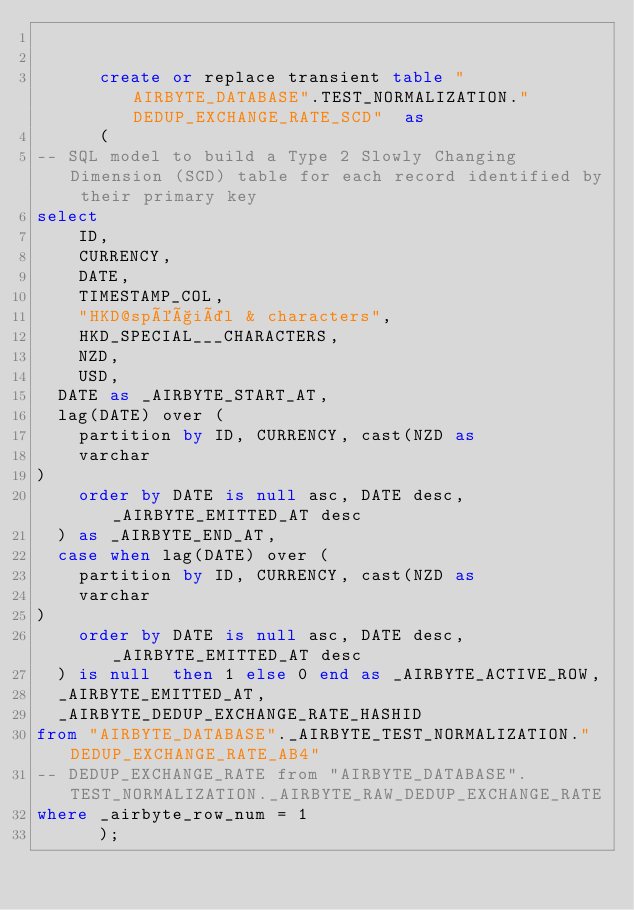<code> <loc_0><loc_0><loc_500><loc_500><_SQL_>

      create or replace transient table "AIRBYTE_DATABASE".TEST_NORMALIZATION."DEDUP_EXCHANGE_RATE_SCD"  as
      (
-- SQL model to build a Type 2 Slowly Changing Dimension (SCD) table for each record identified by their primary key
select
    ID,
    CURRENCY,
    DATE,
    TIMESTAMP_COL,
    "HKD@spéçiäl & characters",
    HKD_SPECIAL___CHARACTERS,
    NZD,
    USD,
  DATE as _AIRBYTE_START_AT,
  lag(DATE) over (
    partition by ID, CURRENCY, cast(NZD as 
    varchar
)
    order by DATE is null asc, DATE desc, _AIRBYTE_EMITTED_AT desc
  ) as _AIRBYTE_END_AT,
  case when lag(DATE) over (
    partition by ID, CURRENCY, cast(NZD as 
    varchar
)
    order by DATE is null asc, DATE desc, _AIRBYTE_EMITTED_AT desc
  ) is null  then 1 else 0 end as _AIRBYTE_ACTIVE_ROW,
  _AIRBYTE_EMITTED_AT,
  _AIRBYTE_DEDUP_EXCHANGE_RATE_HASHID
from "AIRBYTE_DATABASE"._AIRBYTE_TEST_NORMALIZATION."DEDUP_EXCHANGE_RATE_AB4"
-- DEDUP_EXCHANGE_RATE from "AIRBYTE_DATABASE".TEST_NORMALIZATION._AIRBYTE_RAW_DEDUP_EXCHANGE_RATE
where _airbyte_row_num = 1
      );
    </code> 